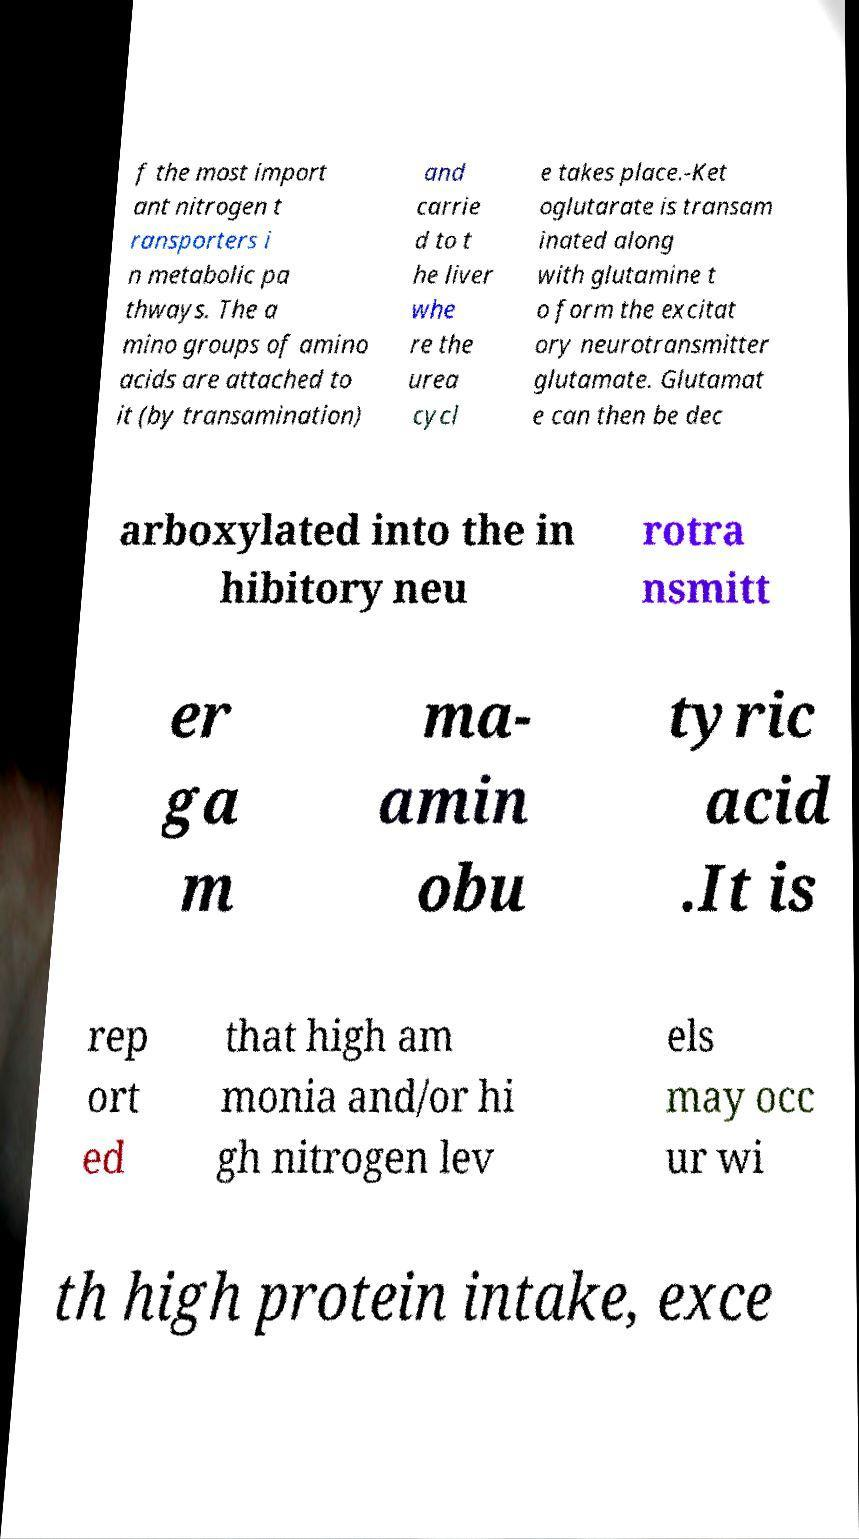Could you extract and type out the text from this image? f the most import ant nitrogen t ransporters i n metabolic pa thways. The a mino groups of amino acids are attached to it (by transamination) and carrie d to t he liver whe re the urea cycl e takes place.-Ket oglutarate is transam inated along with glutamine t o form the excitat ory neurotransmitter glutamate. Glutamat e can then be dec arboxylated into the in hibitory neu rotra nsmitt er ga m ma- amin obu tyric acid .It is rep ort ed that high am monia and/or hi gh nitrogen lev els may occ ur wi th high protein intake, exce 